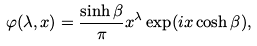Convert formula to latex. <formula><loc_0><loc_0><loc_500><loc_500>\varphi ( \lambda , x ) = \frac { \sinh \beta } { \pi } x ^ { \lambda } \exp ( i x \cosh \beta ) ,</formula> 